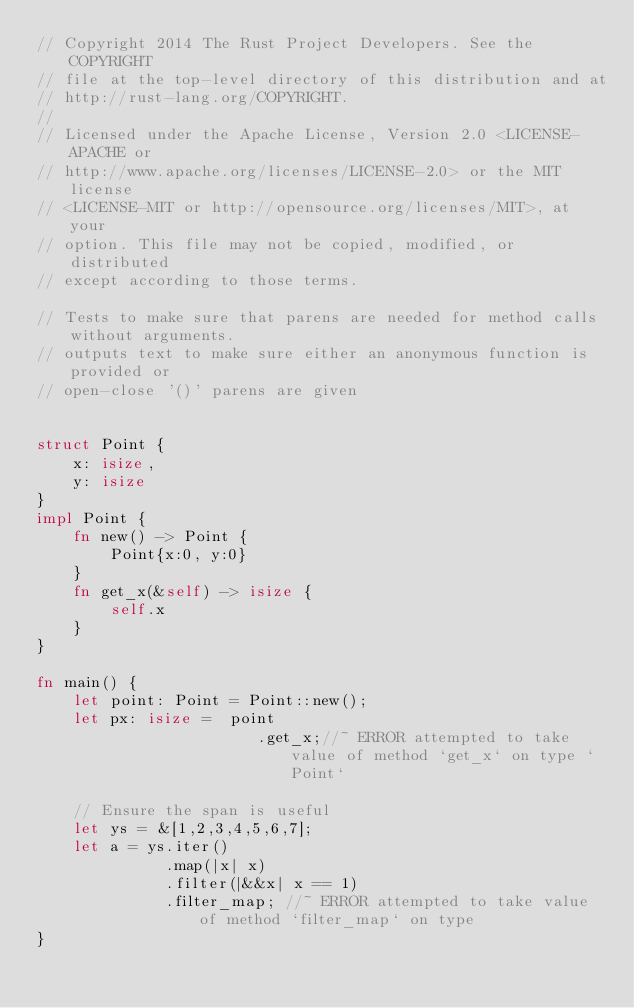<code> <loc_0><loc_0><loc_500><loc_500><_Rust_>// Copyright 2014 The Rust Project Developers. See the COPYRIGHT
// file at the top-level directory of this distribution and at
// http://rust-lang.org/COPYRIGHT.
//
// Licensed under the Apache License, Version 2.0 <LICENSE-APACHE or
// http://www.apache.org/licenses/LICENSE-2.0> or the MIT license
// <LICENSE-MIT or http://opensource.org/licenses/MIT>, at your
// option. This file may not be copied, modified, or distributed
// except according to those terms.

// Tests to make sure that parens are needed for method calls without arguments.
// outputs text to make sure either an anonymous function is provided or
// open-close '()' parens are given


struct Point {
    x: isize,
    y: isize
}
impl Point {
    fn new() -> Point {
        Point{x:0, y:0}
    }
    fn get_x(&self) -> isize {
        self.x
    }
}

fn main() {
    let point: Point = Point::new();
    let px: isize =  point
                        .get_x;//~ ERROR attempted to take value of method `get_x` on type `Point`

    // Ensure the span is useful
    let ys = &[1,2,3,4,5,6,7];
    let a = ys.iter()
              .map(|x| x)
              .filter(|&&x| x == 1)
              .filter_map; //~ ERROR attempted to take value of method `filter_map` on type
}
</code> 